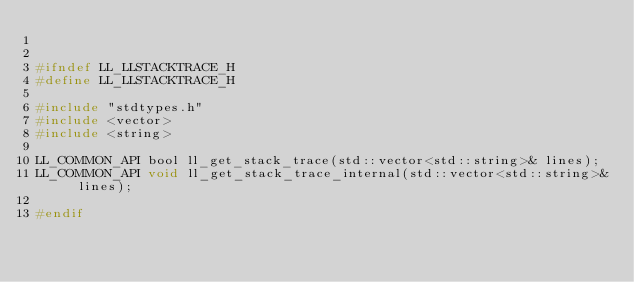Convert code to text. <code><loc_0><loc_0><loc_500><loc_500><_C_>

#ifndef LL_LLSTACKTRACE_H
#define LL_LLSTACKTRACE_H

#include "stdtypes.h"
#include <vector>
#include <string>

LL_COMMON_API bool ll_get_stack_trace(std::vector<std::string>& lines);
LL_COMMON_API void ll_get_stack_trace_internal(std::vector<std::string>& lines);

#endif

</code> 